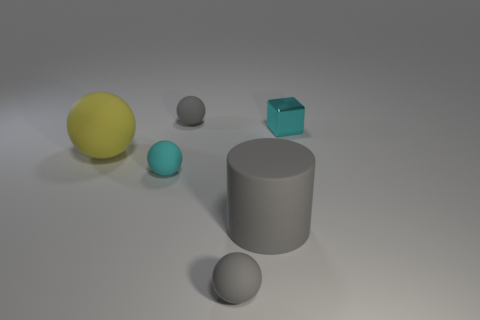Add 1 cyan balls. How many objects exist? 7 Subtract all cylinders. How many objects are left? 5 Add 4 small metal blocks. How many small metal blocks are left? 5 Add 5 yellow cylinders. How many yellow cylinders exist? 5 Subtract 1 cyan blocks. How many objects are left? 5 Subtract all rubber spheres. Subtract all large yellow shiny objects. How many objects are left? 2 